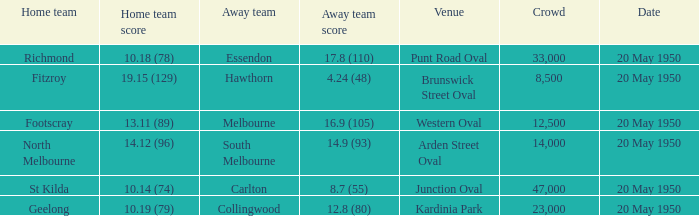What was the date of the game when the away team was south melbourne? 20 May 1950. 